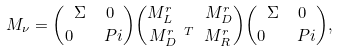Convert formula to latex. <formula><loc_0><loc_0><loc_500><loc_500>M _ { \nu } = { \Sigma \ \ 0 \choose 0 \quad P i } { M ^ { r } _ { L } \quad M ^ { r } _ { D } \choose M ^ { r \ T } _ { D } \ M ^ { r } _ { R } } { \Sigma \ \ 0 \choose 0 \quad P i } ,</formula> 